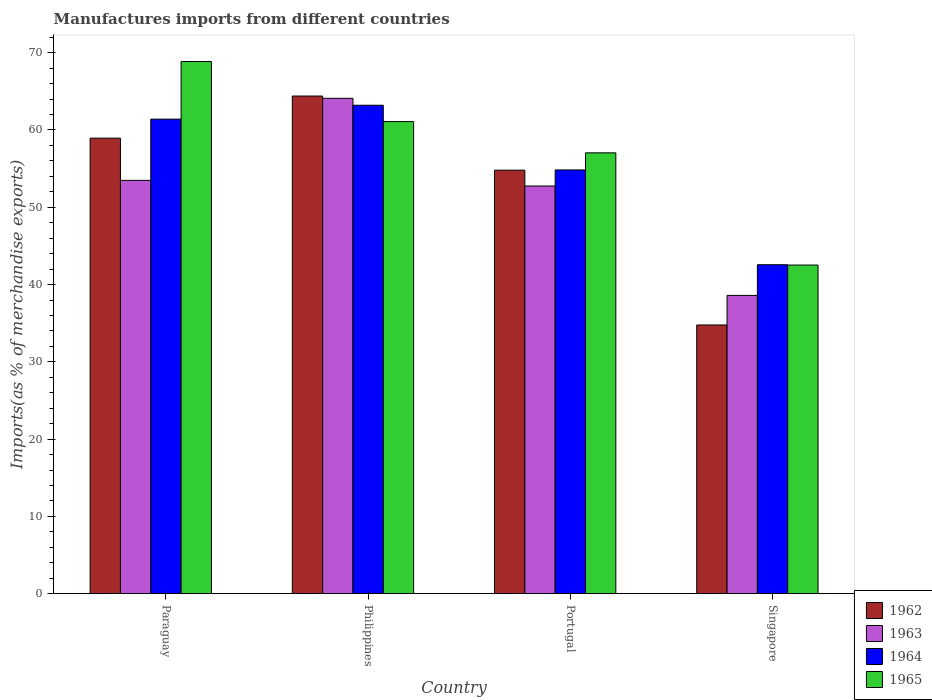How many different coloured bars are there?
Ensure brevity in your answer.  4. Are the number of bars per tick equal to the number of legend labels?
Your answer should be compact. Yes. How many bars are there on the 1st tick from the left?
Offer a very short reply. 4. What is the label of the 1st group of bars from the left?
Give a very brief answer. Paraguay. What is the percentage of imports to different countries in 1963 in Singapore?
Make the answer very short. 38.6. Across all countries, what is the maximum percentage of imports to different countries in 1963?
Keep it short and to the point. 64.1. Across all countries, what is the minimum percentage of imports to different countries in 1965?
Your response must be concise. 42.52. In which country was the percentage of imports to different countries in 1962 minimum?
Offer a terse response. Singapore. What is the total percentage of imports to different countries in 1965 in the graph?
Keep it short and to the point. 229.52. What is the difference between the percentage of imports to different countries in 1965 in Philippines and that in Portugal?
Provide a succinct answer. 4.04. What is the difference between the percentage of imports to different countries in 1964 in Paraguay and the percentage of imports to different countries in 1963 in Portugal?
Provide a short and direct response. 8.65. What is the average percentage of imports to different countries in 1964 per country?
Offer a terse response. 55.5. What is the difference between the percentage of imports to different countries of/in 1964 and percentage of imports to different countries of/in 1962 in Singapore?
Your answer should be compact. 7.8. In how many countries, is the percentage of imports to different countries in 1964 greater than 52 %?
Your answer should be very brief. 3. What is the ratio of the percentage of imports to different countries in 1963 in Philippines to that in Singapore?
Ensure brevity in your answer.  1.66. What is the difference between the highest and the second highest percentage of imports to different countries in 1962?
Provide a succinct answer. 5.45. What is the difference between the highest and the lowest percentage of imports to different countries in 1965?
Your response must be concise. 26.34. Is it the case that in every country, the sum of the percentage of imports to different countries in 1965 and percentage of imports to different countries in 1964 is greater than the sum of percentage of imports to different countries in 1962 and percentage of imports to different countries in 1963?
Offer a terse response. No. What does the 2nd bar from the right in Portugal represents?
Offer a very short reply. 1964. Is it the case that in every country, the sum of the percentage of imports to different countries in 1962 and percentage of imports to different countries in 1963 is greater than the percentage of imports to different countries in 1964?
Provide a short and direct response. Yes. How many bars are there?
Your response must be concise. 16. Are all the bars in the graph horizontal?
Ensure brevity in your answer.  No. How many countries are there in the graph?
Your answer should be very brief. 4. What is the difference between two consecutive major ticks on the Y-axis?
Make the answer very short. 10. Are the values on the major ticks of Y-axis written in scientific E-notation?
Your response must be concise. No. Does the graph contain any zero values?
Provide a succinct answer. No. Does the graph contain grids?
Provide a short and direct response. No. How are the legend labels stacked?
Provide a short and direct response. Vertical. What is the title of the graph?
Your answer should be very brief. Manufactures imports from different countries. Does "2012" appear as one of the legend labels in the graph?
Give a very brief answer. No. What is the label or title of the X-axis?
Your answer should be very brief. Country. What is the label or title of the Y-axis?
Your answer should be compact. Imports(as % of merchandise exports). What is the Imports(as % of merchandise exports) of 1962 in Paraguay?
Give a very brief answer. 58.94. What is the Imports(as % of merchandise exports) of 1963 in Paraguay?
Your answer should be very brief. 53.48. What is the Imports(as % of merchandise exports) of 1964 in Paraguay?
Keep it short and to the point. 61.4. What is the Imports(as % of merchandise exports) in 1965 in Paraguay?
Provide a short and direct response. 68.86. What is the Imports(as % of merchandise exports) of 1962 in Philippines?
Your answer should be compact. 64.4. What is the Imports(as % of merchandise exports) in 1963 in Philippines?
Your response must be concise. 64.1. What is the Imports(as % of merchandise exports) of 1964 in Philippines?
Provide a succinct answer. 63.2. What is the Imports(as % of merchandise exports) of 1965 in Philippines?
Provide a succinct answer. 61.09. What is the Imports(as % of merchandise exports) in 1962 in Portugal?
Make the answer very short. 54.8. What is the Imports(as % of merchandise exports) in 1963 in Portugal?
Your answer should be very brief. 52.75. What is the Imports(as % of merchandise exports) in 1964 in Portugal?
Make the answer very short. 54.83. What is the Imports(as % of merchandise exports) of 1965 in Portugal?
Your response must be concise. 57.04. What is the Imports(as % of merchandise exports) of 1962 in Singapore?
Offer a very short reply. 34.77. What is the Imports(as % of merchandise exports) of 1963 in Singapore?
Ensure brevity in your answer.  38.6. What is the Imports(as % of merchandise exports) in 1964 in Singapore?
Give a very brief answer. 42.56. What is the Imports(as % of merchandise exports) in 1965 in Singapore?
Offer a terse response. 42.52. Across all countries, what is the maximum Imports(as % of merchandise exports) in 1962?
Your response must be concise. 64.4. Across all countries, what is the maximum Imports(as % of merchandise exports) in 1963?
Provide a short and direct response. 64.1. Across all countries, what is the maximum Imports(as % of merchandise exports) of 1964?
Offer a very short reply. 63.2. Across all countries, what is the maximum Imports(as % of merchandise exports) in 1965?
Ensure brevity in your answer.  68.86. Across all countries, what is the minimum Imports(as % of merchandise exports) of 1962?
Your answer should be very brief. 34.77. Across all countries, what is the minimum Imports(as % of merchandise exports) in 1963?
Make the answer very short. 38.6. Across all countries, what is the minimum Imports(as % of merchandise exports) of 1964?
Ensure brevity in your answer.  42.56. Across all countries, what is the minimum Imports(as % of merchandise exports) in 1965?
Offer a very short reply. 42.52. What is the total Imports(as % of merchandise exports) of 1962 in the graph?
Give a very brief answer. 212.91. What is the total Imports(as % of merchandise exports) in 1963 in the graph?
Your response must be concise. 208.92. What is the total Imports(as % of merchandise exports) of 1964 in the graph?
Ensure brevity in your answer.  222. What is the total Imports(as % of merchandise exports) of 1965 in the graph?
Make the answer very short. 229.52. What is the difference between the Imports(as % of merchandise exports) in 1962 in Paraguay and that in Philippines?
Provide a succinct answer. -5.45. What is the difference between the Imports(as % of merchandise exports) of 1963 in Paraguay and that in Philippines?
Your response must be concise. -10.62. What is the difference between the Imports(as % of merchandise exports) in 1964 in Paraguay and that in Philippines?
Ensure brevity in your answer.  -1.8. What is the difference between the Imports(as % of merchandise exports) in 1965 in Paraguay and that in Philippines?
Provide a succinct answer. 7.78. What is the difference between the Imports(as % of merchandise exports) in 1962 in Paraguay and that in Portugal?
Provide a succinct answer. 4.15. What is the difference between the Imports(as % of merchandise exports) in 1963 in Paraguay and that in Portugal?
Give a very brief answer. 0.73. What is the difference between the Imports(as % of merchandise exports) of 1964 in Paraguay and that in Portugal?
Your answer should be very brief. 6.57. What is the difference between the Imports(as % of merchandise exports) in 1965 in Paraguay and that in Portugal?
Keep it short and to the point. 11.82. What is the difference between the Imports(as % of merchandise exports) in 1962 in Paraguay and that in Singapore?
Offer a terse response. 24.17. What is the difference between the Imports(as % of merchandise exports) in 1963 in Paraguay and that in Singapore?
Give a very brief answer. 14.89. What is the difference between the Imports(as % of merchandise exports) in 1964 in Paraguay and that in Singapore?
Offer a terse response. 18.84. What is the difference between the Imports(as % of merchandise exports) of 1965 in Paraguay and that in Singapore?
Offer a very short reply. 26.34. What is the difference between the Imports(as % of merchandise exports) in 1962 in Philippines and that in Portugal?
Keep it short and to the point. 9.6. What is the difference between the Imports(as % of merchandise exports) of 1963 in Philippines and that in Portugal?
Ensure brevity in your answer.  11.35. What is the difference between the Imports(as % of merchandise exports) in 1964 in Philippines and that in Portugal?
Offer a terse response. 8.37. What is the difference between the Imports(as % of merchandise exports) of 1965 in Philippines and that in Portugal?
Provide a succinct answer. 4.04. What is the difference between the Imports(as % of merchandise exports) of 1962 in Philippines and that in Singapore?
Ensure brevity in your answer.  29.63. What is the difference between the Imports(as % of merchandise exports) in 1963 in Philippines and that in Singapore?
Offer a very short reply. 25.5. What is the difference between the Imports(as % of merchandise exports) of 1964 in Philippines and that in Singapore?
Your answer should be very brief. 20.64. What is the difference between the Imports(as % of merchandise exports) of 1965 in Philippines and that in Singapore?
Offer a very short reply. 18.57. What is the difference between the Imports(as % of merchandise exports) in 1962 in Portugal and that in Singapore?
Keep it short and to the point. 20.03. What is the difference between the Imports(as % of merchandise exports) in 1963 in Portugal and that in Singapore?
Give a very brief answer. 14.16. What is the difference between the Imports(as % of merchandise exports) in 1964 in Portugal and that in Singapore?
Keep it short and to the point. 12.27. What is the difference between the Imports(as % of merchandise exports) of 1965 in Portugal and that in Singapore?
Your answer should be very brief. 14.52. What is the difference between the Imports(as % of merchandise exports) in 1962 in Paraguay and the Imports(as % of merchandise exports) in 1963 in Philippines?
Offer a very short reply. -5.15. What is the difference between the Imports(as % of merchandise exports) of 1962 in Paraguay and the Imports(as % of merchandise exports) of 1964 in Philippines?
Keep it short and to the point. -4.26. What is the difference between the Imports(as % of merchandise exports) in 1962 in Paraguay and the Imports(as % of merchandise exports) in 1965 in Philippines?
Keep it short and to the point. -2.14. What is the difference between the Imports(as % of merchandise exports) of 1963 in Paraguay and the Imports(as % of merchandise exports) of 1964 in Philippines?
Offer a very short reply. -9.72. What is the difference between the Imports(as % of merchandise exports) of 1963 in Paraguay and the Imports(as % of merchandise exports) of 1965 in Philippines?
Make the answer very short. -7.61. What is the difference between the Imports(as % of merchandise exports) of 1964 in Paraguay and the Imports(as % of merchandise exports) of 1965 in Philippines?
Your response must be concise. 0.32. What is the difference between the Imports(as % of merchandise exports) of 1962 in Paraguay and the Imports(as % of merchandise exports) of 1963 in Portugal?
Your answer should be compact. 6.19. What is the difference between the Imports(as % of merchandise exports) in 1962 in Paraguay and the Imports(as % of merchandise exports) in 1964 in Portugal?
Your answer should be compact. 4.11. What is the difference between the Imports(as % of merchandise exports) in 1962 in Paraguay and the Imports(as % of merchandise exports) in 1965 in Portugal?
Keep it short and to the point. 1.9. What is the difference between the Imports(as % of merchandise exports) in 1963 in Paraguay and the Imports(as % of merchandise exports) in 1964 in Portugal?
Make the answer very short. -1.35. What is the difference between the Imports(as % of merchandise exports) in 1963 in Paraguay and the Imports(as % of merchandise exports) in 1965 in Portugal?
Offer a very short reply. -3.56. What is the difference between the Imports(as % of merchandise exports) of 1964 in Paraguay and the Imports(as % of merchandise exports) of 1965 in Portugal?
Provide a succinct answer. 4.36. What is the difference between the Imports(as % of merchandise exports) in 1962 in Paraguay and the Imports(as % of merchandise exports) in 1963 in Singapore?
Offer a very short reply. 20.35. What is the difference between the Imports(as % of merchandise exports) in 1962 in Paraguay and the Imports(as % of merchandise exports) in 1964 in Singapore?
Keep it short and to the point. 16.38. What is the difference between the Imports(as % of merchandise exports) in 1962 in Paraguay and the Imports(as % of merchandise exports) in 1965 in Singapore?
Give a very brief answer. 16.42. What is the difference between the Imports(as % of merchandise exports) of 1963 in Paraguay and the Imports(as % of merchandise exports) of 1964 in Singapore?
Make the answer very short. 10.92. What is the difference between the Imports(as % of merchandise exports) of 1963 in Paraguay and the Imports(as % of merchandise exports) of 1965 in Singapore?
Keep it short and to the point. 10.96. What is the difference between the Imports(as % of merchandise exports) of 1964 in Paraguay and the Imports(as % of merchandise exports) of 1965 in Singapore?
Your answer should be very brief. 18.88. What is the difference between the Imports(as % of merchandise exports) in 1962 in Philippines and the Imports(as % of merchandise exports) in 1963 in Portugal?
Provide a succinct answer. 11.65. What is the difference between the Imports(as % of merchandise exports) of 1962 in Philippines and the Imports(as % of merchandise exports) of 1964 in Portugal?
Your answer should be compact. 9.57. What is the difference between the Imports(as % of merchandise exports) in 1962 in Philippines and the Imports(as % of merchandise exports) in 1965 in Portugal?
Make the answer very short. 7.35. What is the difference between the Imports(as % of merchandise exports) of 1963 in Philippines and the Imports(as % of merchandise exports) of 1964 in Portugal?
Provide a short and direct response. 9.27. What is the difference between the Imports(as % of merchandise exports) in 1963 in Philippines and the Imports(as % of merchandise exports) in 1965 in Portugal?
Give a very brief answer. 7.05. What is the difference between the Imports(as % of merchandise exports) of 1964 in Philippines and the Imports(as % of merchandise exports) of 1965 in Portugal?
Ensure brevity in your answer.  6.16. What is the difference between the Imports(as % of merchandise exports) in 1962 in Philippines and the Imports(as % of merchandise exports) in 1963 in Singapore?
Offer a very short reply. 25.8. What is the difference between the Imports(as % of merchandise exports) of 1962 in Philippines and the Imports(as % of merchandise exports) of 1964 in Singapore?
Offer a very short reply. 21.83. What is the difference between the Imports(as % of merchandise exports) of 1962 in Philippines and the Imports(as % of merchandise exports) of 1965 in Singapore?
Provide a succinct answer. 21.87. What is the difference between the Imports(as % of merchandise exports) of 1963 in Philippines and the Imports(as % of merchandise exports) of 1964 in Singapore?
Offer a very short reply. 21.53. What is the difference between the Imports(as % of merchandise exports) in 1963 in Philippines and the Imports(as % of merchandise exports) in 1965 in Singapore?
Offer a terse response. 21.58. What is the difference between the Imports(as % of merchandise exports) of 1964 in Philippines and the Imports(as % of merchandise exports) of 1965 in Singapore?
Keep it short and to the point. 20.68. What is the difference between the Imports(as % of merchandise exports) in 1962 in Portugal and the Imports(as % of merchandise exports) in 1963 in Singapore?
Offer a terse response. 16.2. What is the difference between the Imports(as % of merchandise exports) in 1962 in Portugal and the Imports(as % of merchandise exports) in 1964 in Singapore?
Offer a very short reply. 12.23. What is the difference between the Imports(as % of merchandise exports) in 1962 in Portugal and the Imports(as % of merchandise exports) in 1965 in Singapore?
Your answer should be very brief. 12.28. What is the difference between the Imports(as % of merchandise exports) of 1963 in Portugal and the Imports(as % of merchandise exports) of 1964 in Singapore?
Give a very brief answer. 10.19. What is the difference between the Imports(as % of merchandise exports) of 1963 in Portugal and the Imports(as % of merchandise exports) of 1965 in Singapore?
Ensure brevity in your answer.  10.23. What is the difference between the Imports(as % of merchandise exports) of 1964 in Portugal and the Imports(as % of merchandise exports) of 1965 in Singapore?
Make the answer very short. 12.31. What is the average Imports(as % of merchandise exports) of 1962 per country?
Give a very brief answer. 53.23. What is the average Imports(as % of merchandise exports) in 1963 per country?
Give a very brief answer. 52.23. What is the average Imports(as % of merchandise exports) of 1964 per country?
Offer a very short reply. 55.5. What is the average Imports(as % of merchandise exports) in 1965 per country?
Make the answer very short. 57.38. What is the difference between the Imports(as % of merchandise exports) in 1962 and Imports(as % of merchandise exports) in 1963 in Paraguay?
Keep it short and to the point. 5.46. What is the difference between the Imports(as % of merchandise exports) of 1962 and Imports(as % of merchandise exports) of 1964 in Paraguay?
Ensure brevity in your answer.  -2.46. What is the difference between the Imports(as % of merchandise exports) of 1962 and Imports(as % of merchandise exports) of 1965 in Paraguay?
Your response must be concise. -9.92. What is the difference between the Imports(as % of merchandise exports) in 1963 and Imports(as % of merchandise exports) in 1964 in Paraguay?
Your answer should be compact. -7.92. What is the difference between the Imports(as % of merchandise exports) of 1963 and Imports(as % of merchandise exports) of 1965 in Paraguay?
Your response must be concise. -15.38. What is the difference between the Imports(as % of merchandise exports) in 1964 and Imports(as % of merchandise exports) in 1965 in Paraguay?
Your answer should be compact. -7.46. What is the difference between the Imports(as % of merchandise exports) in 1962 and Imports(as % of merchandise exports) in 1963 in Philippines?
Offer a terse response. 0.3. What is the difference between the Imports(as % of merchandise exports) of 1962 and Imports(as % of merchandise exports) of 1964 in Philippines?
Give a very brief answer. 1.19. What is the difference between the Imports(as % of merchandise exports) of 1962 and Imports(as % of merchandise exports) of 1965 in Philippines?
Offer a very short reply. 3.31. What is the difference between the Imports(as % of merchandise exports) of 1963 and Imports(as % of merchandise exports) of 1964 in Philippines?
Provide a succinct answer. 0.89. What is the difference between the Imports(as % of merchandise exports) of 1963 and Imports(as % of merchandise exports) of 1965 in Philippines?
Give a very brief answer. 3.01. What is the difference between the Imports(as % of merchandise exports) of 1964 and Imports(as % of merchandise exports) of 1965 in Philippines?
Your response must be concise. 2.12. What is the difference between the Imports(as % of merchandise exports) of 1962 and Imports(as % of merchandise exports) of 1963 in Portugal?
Your response must be concise. 2.05. What is the difference between the Imports(as % of merchandise exports) of 1962 and Imports(as % of merchandise exports) of 1964 in Portugal?
Your answer should be compact. -0.03. What is the difference between the Imports(as % of merchandise exports) in 1962 and Imports(as % of merchandise exports) in 1965 in Portugal?
Your response must be concise. -2.24. What is the difference between the Imports(as % of merchandise exports) in 1963 and Imports(as % of merchandise exports) in 1964 in Portugal?
Offer a very short reply. -2.08. What is the difference between the Imports(as % of merchandise exports) of 1963 and Imports(as % of merchandise exports) of 1965 in Portugal?
Offer a very short reply. -4.29. What is the difference between the Imports(as % of merchandise exports) of 1964 and Imports(as % of merchandise exports) of 1965 in Portugal?
Ensure brevity in your answer.  -2.21. What is the difference between the Imports(as % of merchandise exports) of 1962 and Imports(as % of merchandise exports) of 1963 in Singapore?
Your response must be concise. -3.83. What is the difference between the Imports(as % of merchandise exports) in 1962 and Imports(as % of merchandise exports) in 1964 in Singapore?
Keep it short and to the point. -7.8. What is the difference between the Imports(as % of merchandise exports) in 1962 and Imports(as % of merchandise exports) in 1965 in Singapore?
Your response must be concise. -7.75. What is the difference between the Imports(as % of merchandise exports) of 1963 and Imports(as % of merchandise exports) of 1964 in Singapore?
Your answer should be compact. -3.97. What is the difference between the Imports(as % of merchandise exports) in 1963 and Imports(as % of merchandise exports) in 1965 in Singapore?
Give a very brief answer. -3.93. What is the difference between the Imports(as % of merchandise exports) in 1964 and Imports(as % of merchandise exports) in 1965 in Singapore?
Ensure brevity in your answer.  0.04. What is the ratio of the Imports(as % of merchandise exports) of 1962 in Paraguay to that in Philippines?
Provide a succinct answer. 0.92. What is the ratio of the Imports(as % of merchandise exports) in 1963 in Paraguay to that in Philippines?
Keep it short and to the point. 0.83. What is the ratio of the Imports(as % of merchandise exports) of 1964 in Paraguay to that in Philippines?
Ensure brevity in your answer.  0.97. What is the ratio of the Imports(as % of merchandise exports) of 1965 in Paraguay to that in Philippines?
Provide a short and direct response. 1.13. What is the ratio of the Imports(as % of merchandise exports) of 1962 in Paraguay to that in Portugal?
Keep it short and to the point. 1.08. What is the ratio of the Imports(as % of merchandise exports) in 1963 in Paraguay to that in Portugal?
Make the answer very short. 1.01. What is the ratio of the Imports(as % of merchandise exports) of 1964 in Paraguay to that in Portugal?
Keep it short and to the point. 1.12. What is the ratio of the Imports(as % of merchandise exports) of 1965 in Paraguay to that in Portugal?
Your response must be concise. 1.21. What is the ratio of the Imports(as % of merchandise exports) of 1962 in Paraguay to that in Singapore?
Your answer should be very brief. 1.7. What is the ratio of the Imports(as % of merchandise exports) of 1963 in Paraguay to that in Singapore?
Your answer should be very brief. 1.39. What is the ratio of the Imports(as % of merchandise exports) of 1964 in Paraguay to that in Singapore?
Offer a terse response. 1.44. What is the ratio of the Imports(as % of merchandise exports) in 1965 in Paraguay to that in Singapore?
Keep it short and to the point. 1.62. What is the ratio of the Imports(as % of merchandise exports) in 1962 in Philippines to that in Portugal?
Your response must be concise. 1.18. What is the ratio of the Imports(as % of merchandise exports) of 1963 in Philippines to that in Portugal?
Your answer should be very brief. 1.22. What is the ratio of the Imports(as % of merchandise exports) in 1964 in Philippines to that in Portugal?
Provide a succinct answer. 1.15. What is the ratio of the Imports(as % of merchandise exports) in 1965 in Philippines to that in Portugal?
Your response must be concise. 1.07. What is the ratio of the Imports(as % of merchandise exports) in 1962 in Philippines to that in Singapore?
Provide a short and direct response. 1.85. What is the ratio of the Imports(as % of merchandise exports) in 1963 in Philippines to that in Singapore?
Give a very brief answer. 1.66. What is the ratio of the Imports(as % of merchandise exports) in 1964 in Philippines to that in Singapore?
Provide a short and direct response. 1.48. What is the ratio of the Imports(as % of merchandise exports) in 1965 in Philippines to that in Singapore?
Provide a succinct answer. 1.44. What is the ratio of the Imports(as % of merchandise exports) in 1962 in Portugal to that in Singapore?
Your response must be concise. 1.58. What is the ratio of the Imports(as % of merchandise exports) of 1963 in Portugal to that in Singapore?
Your response must be concise. 1.37. What is the ratio of the Imports(as % of merchandise exports) of 1964 in Portugal to that in Singapore?
Ensure brevity in your answer.  1.29. What is the ratio of the Imports(as % of merchandise exports) of 1965 in Portugal to that in Singapore?
Offer a terse response. 1.34. What is the difference between the highest and the second highest Imports(as % of merchandise exports) in 1962?
Keep it short and to the point. 5.45. What is the difference between the highest and the second highest Imports(as % of merchandise exports) of 1963?
Give a very brief answer. 10.62. What is the difference between the highest and the second highest Imports(as % of merchandise exports) in 1964?
Your answer should be compact. 1.8. What is the difference between the highest and the second highest Imports(as % of merchandise exports) of 1965?
Offer a terse response. 7.78. What is the difference between the highest and the lowest Imports(as % of merchandise exports) of 1962?
Offer a very short reply. 29.63. What is the difference between the highest and the lowest Imports(as % of merchandise exports) in 1963?
Your answer should be very brief. 25.5. What is the difference between the highest and the lowest Imports(as % of merchandise exports) in 1964?
Your answer should be compact. 20.64. What is the difference between the highest and the lowest Imports(as % of merchandise exports) of 1965?
Your answer should be very brief. 26.34. 